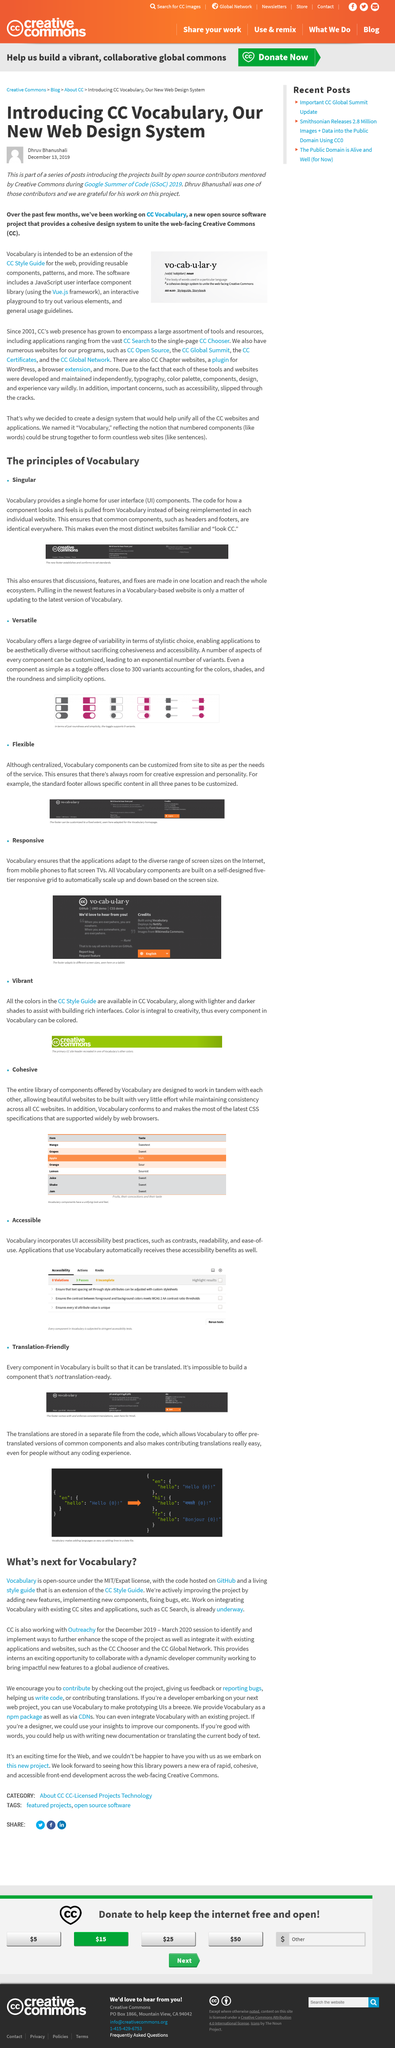Outline some significant characteristics in this image. For the code of different website components for CC affiliated websites, please refer to the vocabulary. The article was written on December 13, 2019. To update a vocabulary-based website with the latest features, one would pull in the newest information by updating to the latest version of the vocabulary. Google Summer of Code is an annual program sponsored by Google in which participants, known as students, work on open-source projects over a three-month period during the summer. Vocabulary's code can be accessed on GitHub. 